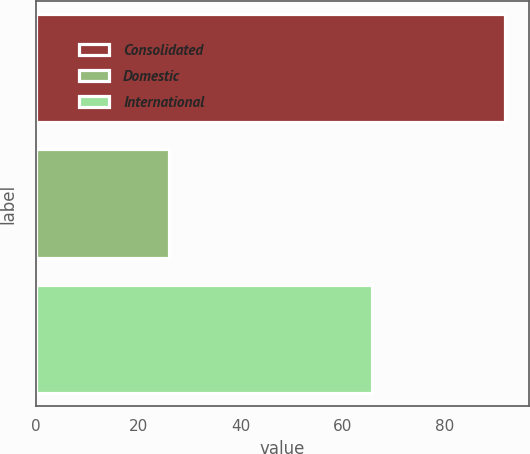Convert chart to OTSL. <chart><loc_0><loc_0><loc_500><loc_500><bar_chart><fcel>Consolidated<fcel>Domestic<fcel>International<nl><fcel>91.8<fcel>26.1<fcel>65.7<nl></chart> 